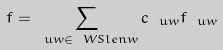Convert formula to latex. <formula><loc_0><loc_0><loc_500><loc_500>f = \sum _ { \ u w \in \ W S l e n w } c _ { \ u w } f _ { \ u w }</formula> 